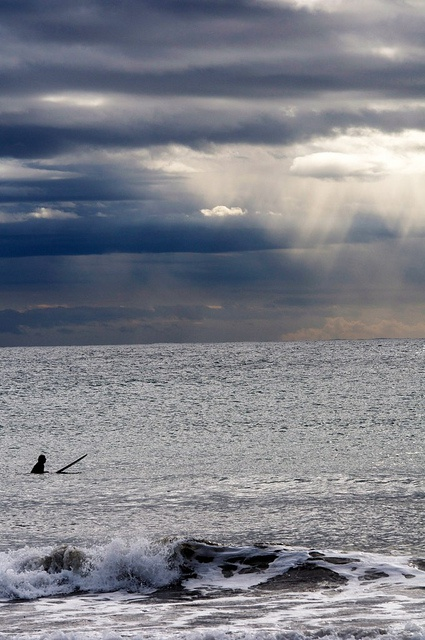Describe the objects in this image and their specific colors. I can see people in navy, black, gray, and lightgray tones and surfboard in navy, black, gray, and darkgray tones in this image. 